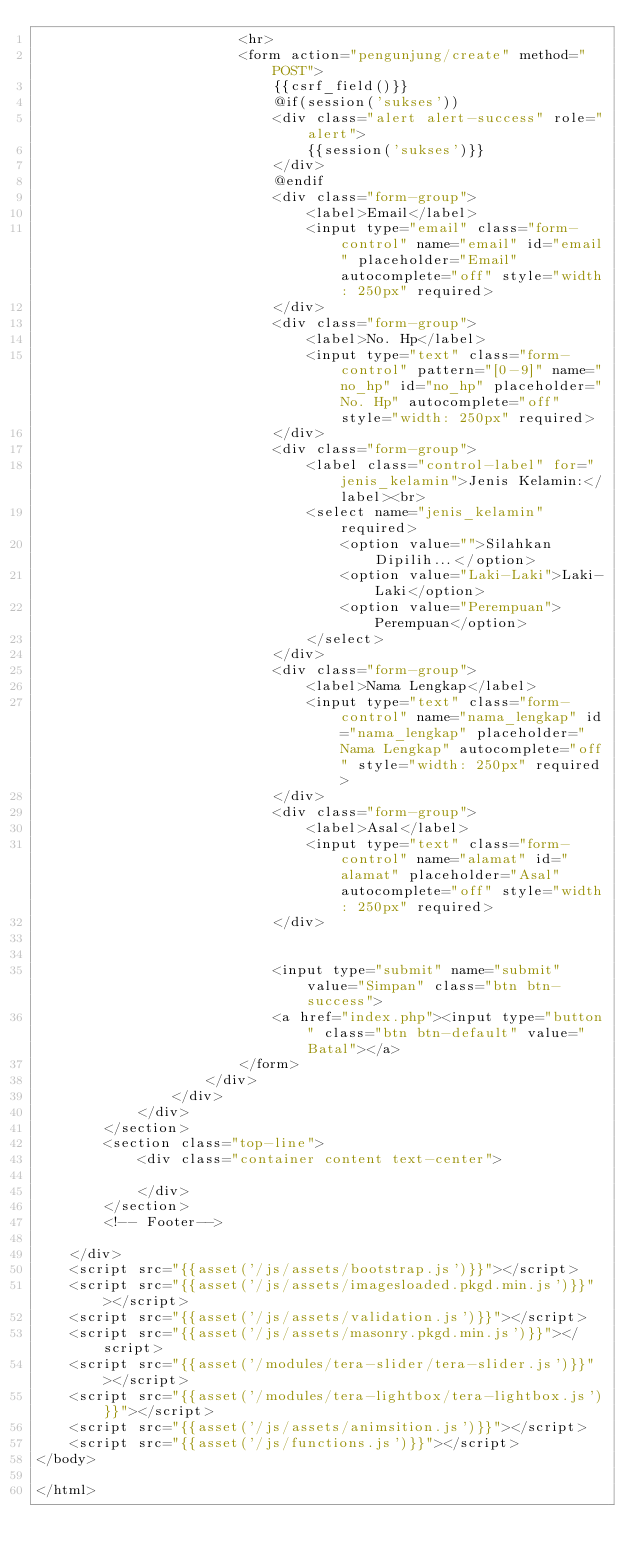Convert code to text. <code><loc_0><loc_0><loc_500><loc_500><_PHP_>                        <hr>
                        <form action="pengunjung/create" method="POST">
                            {{csrf_field()}}
                            @if(session('sukses'))
                            <div class="alert alert-success" role="alert">
                                {{session('sukses')}}
                            </div>
                            @endif
                            <div class="form-group">
                                <label>Email</label>
                                <input type="email" class="form-control" name="email" id="email" placeholder="Email" autocomplete="off" style="width: 250px" required>
                            </div>
                            <div class="form-group">
                                <label>No. Hp</label>
                                <input type="text" class="form-control" pattern="[0-9]" name="no_hp" id="no_hp" placeholder="No. Hp" autocomplete="off" style="width: 250px" required>
                            </div>
                            <div class="form-group">
                                <label class="control-label" for="jenis_kelamin">Jenis Kelamin:</label><br>
                                <select name="jenis_kelamin" required>
                                    <option value="">Silahkan Dipilih...</option>
                                    <option value="Laki-Laki">Laki-Laki</option>
                                    <option value="Perempuan">Perempuan</option>
                                </select>
                            </div>
                            <div class="form-group">
                                <label>Nama Lengkap</label>
                                <input type="text" class="form-control" name="nama_lengkap" id="nama_lengkap" placeholder="Nama Lengkap" autocomplete="off" style="width: 250px" required>
                            </div>
                            <div class="form-group">
                                <label>Asal</label>
                                <input type="text" class="form-control" name="alamat" id="alamat" placeholder="Asal" autocomplete="off" style="width: 250px" required>
                            </div>


                            <input type="submit" name="submit" value="Simpan" class="btn btn-success">
                            <a href="index.php"><input type="button" class="btn btn-default" value="Batal"></a>
                        </form>
                    </div>
                </div>
            </div>
        </section>
        <section class="top-line">
            <div class="container content text-center">

            </div>
        </section>
        <!-- Footer-->

    </div>
    <script src="{{asset('/js/assets/bootstrap.js')}}"></script>
    <script src="{{asset('/js/assets/imagesloaded.pkgd.min.js')}}"></script>
    <script src="{{asset('/js/assets/validation.js')}}"></script>
    <script src="{{asset('/js/assets/masonry.pkgd.min.js')}}"></script>
    <script src="{{asset('/modules/tera-slider/tera-slider.js')}}"></script>
    <script src="{{asset('/modules/tera-lightbox/tera-lightbox.js')}}"></script>
    <script src="{{asset('/js/assets/animsition.js')}}"></script>
    <script src="{{asset('/js/functions.js')}}"></script>
</body>

</html></code> 